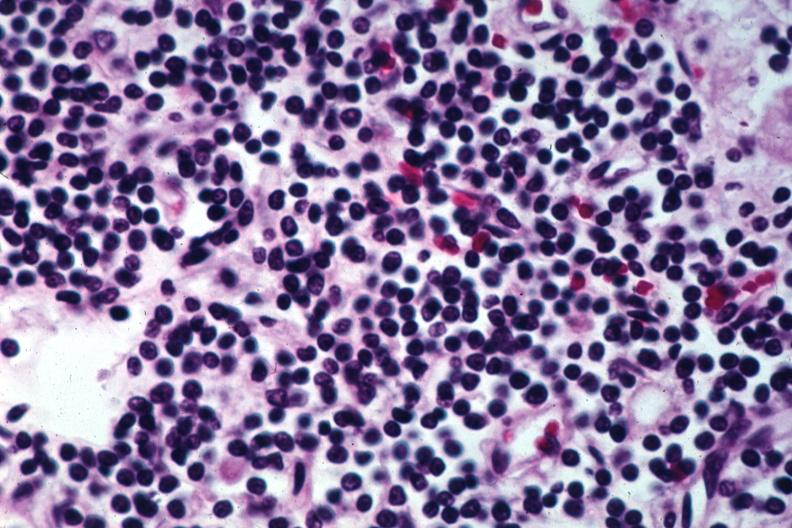s 70yof present?
Answer the question using a single word or phrase. No 